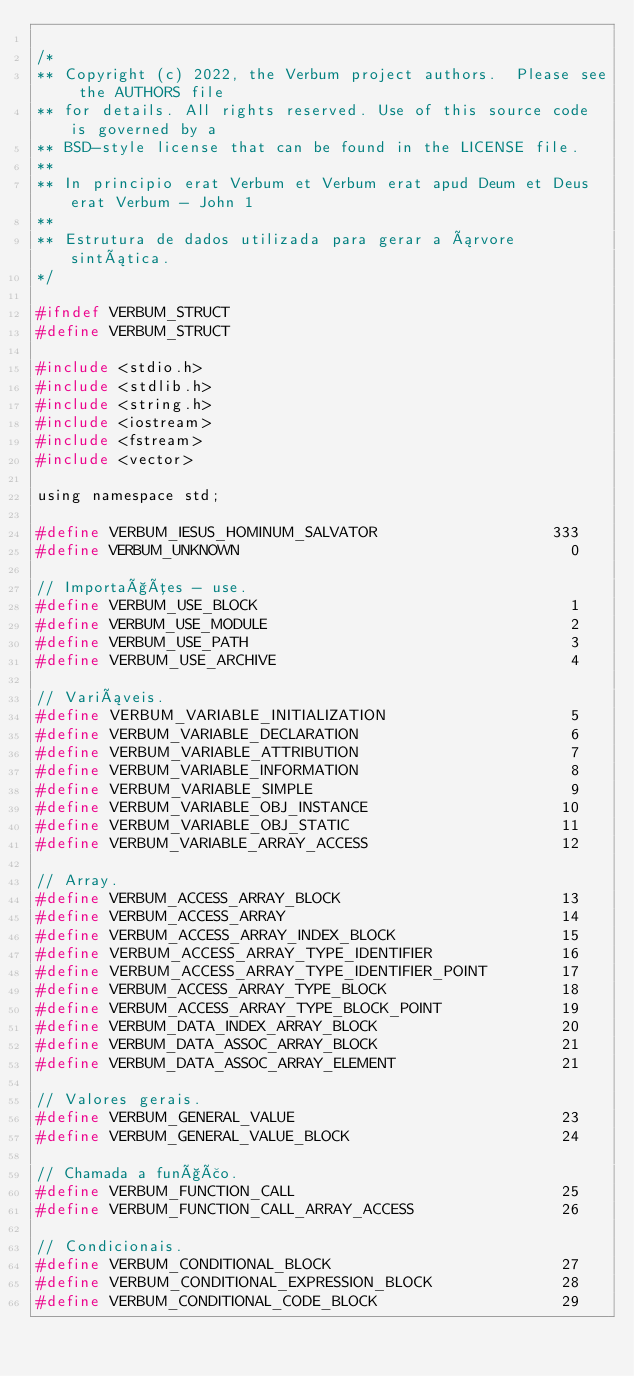Convert code to text. <code><loc_0><loc_0><loc_500><loc_500><_C_>
/*
** Copyright (c) 2022, the Verbum project authors.  Please see the AUTHORS file
** for details. All rights reserved. Use of this source code is governed by a
** BSD-style license that can be found in the LICENSE file.
**
** In principio erat Verbum et Verbum erat apud Deum et Deus erat Verbum - John 1
**
** Estrutura de dados utilizada para gerar a árvore sintática.
*/

#ifndef VERBUM_STRUCT
#define VERBUM_STRUCT

#include <stdio.h>
#include <stdlib.h>
#include <string.h>
#include <iostream>
#include <fstream>
#include <vector>

using namespace std;

#define VERBUM_IESUS_HOMINUM_SALVATOR                   333
#define VERBUM_UNKNOWN                                    0

// Importações - use.
#define VERBUM_USE_BLOCK                                  1
#define VERBUM_USE_MODULE                                 2
#define VERBUM_USE_PATH                                   3
#define VERBUM_USE_ARCHIVE                                4

// Variáveis.
#define VERBUM_VARIABLE_INITIALIZATION                    5
#define VERBUM_VARIABLE_DECLARATION                       6
#define VERBUM_VARIABLE_ATTRIBUTION                       7
#define VERBUM_VARIABLE_INFORMATION                       8
#define VERBUM_VARIABLE_SIMPLE                            9
#define VERBUM_VARIABLE_OBJ_INSTANCE                     10
#define VERBUM_VARIABLE_OBJ_STATIC                       11
#define VERBUM_VARIABLE_ARRAY_ACCESS                     12

// Array.
#define VERBUM_ACCESS_ARRAY_BLOCK                        13
#define VERBUM_ACCESS_ARRAY                              14
#define VERBUM_ACCESS_ARRAY_INDEX_BLOCK                  15
#define VERBUM_ACCESS_ARRAY_TYPE_IDENTIFIER              16
#define VERBUM_ACCESS_ARRAY_TYPE_IDENTIFIER_POINT        17
#define VERBUM_ACCESS_ARRAY_TYPE_BLOCK                   18
#define VERBUM_ACCESS_ARRAY_TYPE_BLOCK_POINT             19
#define VERBUM_DATA_INDEX_ARRAY_BLOCK                    20
#define VERBUM_DATA_ASSOC_ARRAY_BLOCK                    21
#define VERBUM_DATA_ASSOC_ARRAY_ELEMENT                  21

// Valores gerais.
#define VERBUM_GENERAL_VALUE                             23
#define VERBUM_GENERAL_VALUE_BLOCK                       24

// Chamada a função.
#define VERBUM_FUNCTION_CALL                             25
#define VERBUM_FUNCTION_CALL_ARRAY_ACCESS                26

// Condicionais.
#define VERBUM_CONDITIONAL_BLOCK                         27
#define VERBUM_CONDITIONAL_EXPRESSION_BLOCK              28
#define VERBUM_CONDITIONAL_CODE_BLOCK                    29</code> 